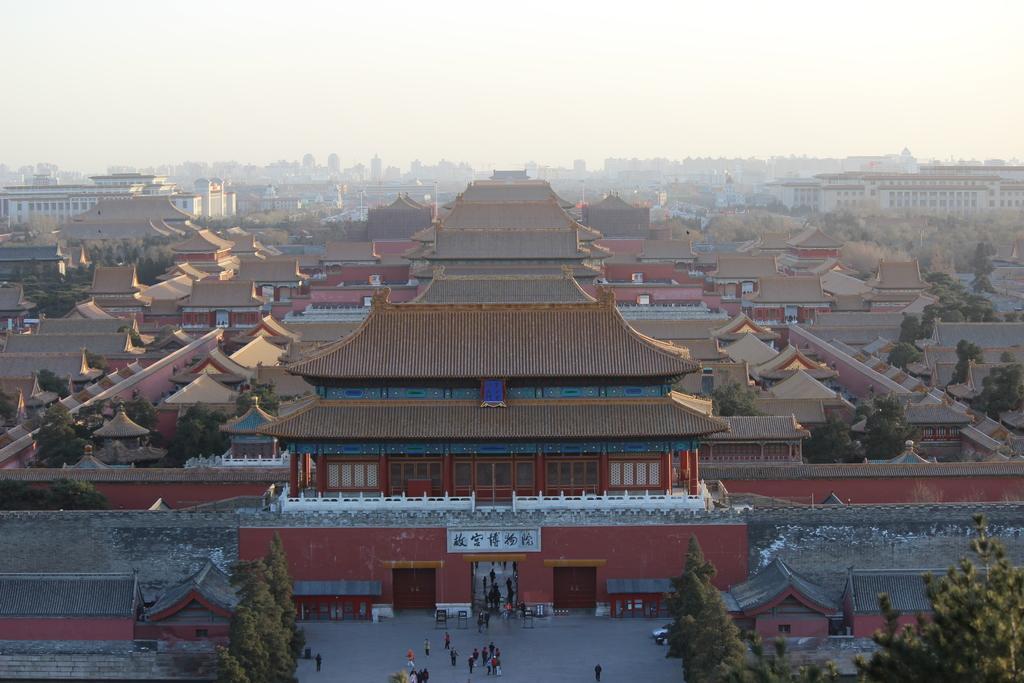How would you summarize this image in a sentence or two? In this picture, we can see some buildings with windows, trees, the road, a few people, and the sky. 